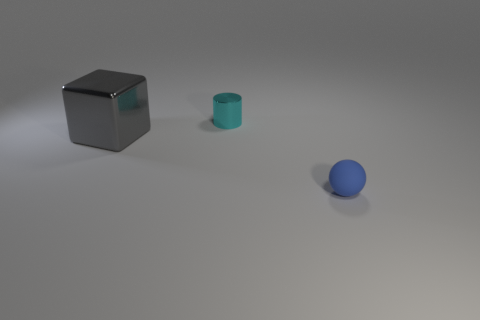What size is the thing left of the small object to the left of the tiny thing in front of the small cyan metal cylinder?
Your answer should be compact. Large. What number of other objects are the same color as the tiny shiny cylinder?
Offer a very short reply. 0. The other thing that is the same size as the blue rubber object is what shape?
Your response must be concise. Cylinder. There is a thing to the right of the cylinder; what size is it?
Ensure brevity in your answer.  Small. Is the color of the object in front of the block the same as the metal thing that is behind the metal block?
Offer a very short reply. No. There is a thing that is to the right of the tiny thing behind the tiny object on the right side of the tiny cylinder; what is it made of?
Your answer should be compact. Rubber. Is there a blue ball that has the same size as the cyan object?
Offer a very short reply. Yes. What is the material of the other thing that is the same size as the cyan thing?
Your response must be concise. Rubber. There is a metal object that is in front of the cyan object; what is its shape?
Provide a short and direct response. Cube. Do the small thing that is in front of the gray shiny object and the object behind the big gray metallic object have the same material?
Your answer should be compact. No. 